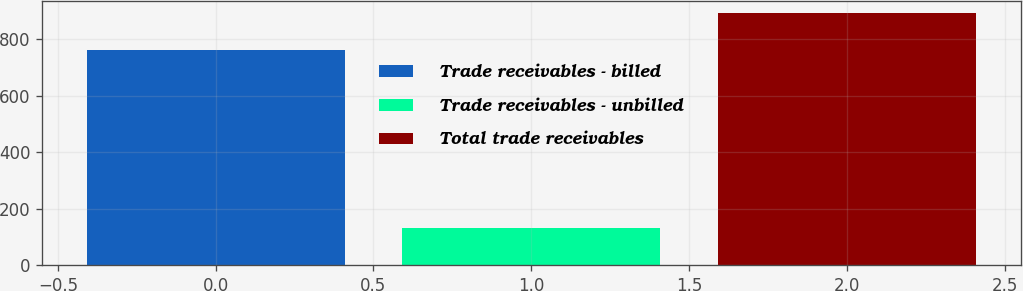Convert chart. <chart><loc_0><loc_0><loc_500><loc_500><bar_chart><fcel>Trade receivables - billed<fcel>Trade receivables - unbilled<fcel>Total trade receivables<nl><fcel>760.8<fcel>130.8<fcel>891.6<nl></chart> 